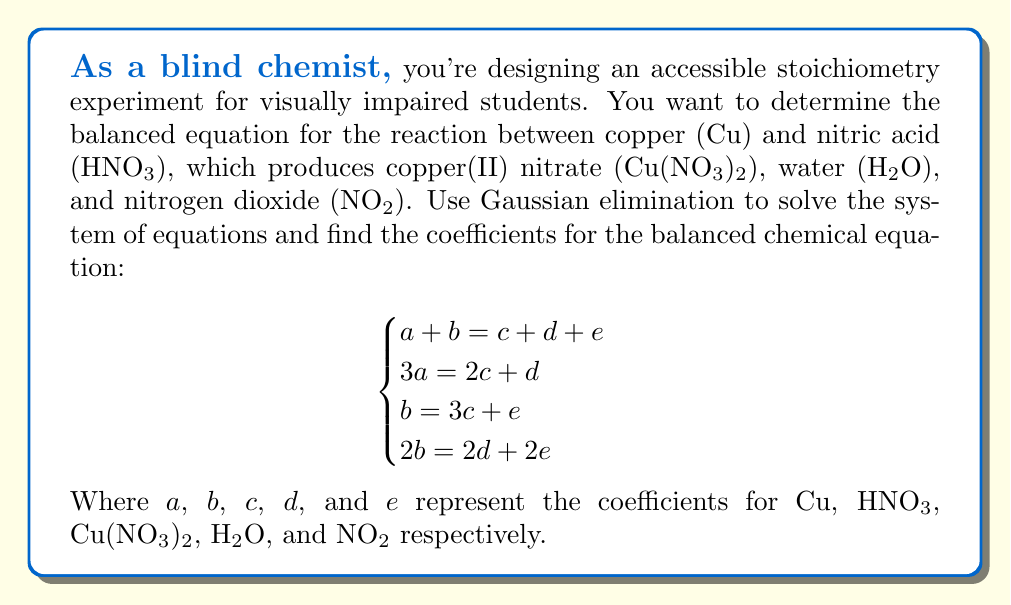Can you solve this math problem? Let's solve this system using Gaussian elimination:

1) First, we'll create an augmented matrix:

$$\begin{bmatrix}
1 & 1 & -1 & -1 & -1 & 0 \\
3 & 0 & -2 & -1 & 0 & 0 \\
0 & 1 & -3 & 0 & -1 & 0 \\
0 & 2 & 0 & -2 & -2 & 0
\end{bmatrix}$$

2) Multiply row 1 by -3 and add to row 2:

$$\begin{bmatrix}
1 & 1 & -1 & -1 & -1 & 0 \\
0 & -3 & 1 & 2 & 3 & 0 \\
0 & 1 & -3 & 0 & -1 & 0 \\
0 & 2 & 0 & -2 & -2 & 0
\end{bmatrix}$$

3) Add row 2 to 3 times row 3:

$$\begin{bmatrix}
1 & 1 & -1 & -1 & -1 & 0 \\
0 & -3 & 1 & 2 & 3 & 0 \\
0 & 0 & -8 & 2 & 0 & 0 \\
0 & 2 & 0 & -2 & -2 & 0
\end{bmatrix}$$

4) Multiply row 3 by -1/8:

$$\begin{bmatrix}
1 & 1 & -1 & -1 & -1 & 0 \\
0 & -3 & 1 & 2 & 3 & 0 \\
0 & 0 & 1 & -1/4 & 0 & 0 \\
0 & 2 & 0 & -2 & -2 & 0
\end{bmatrix}$$

5) Use row 3 to eliminate column 3 in other rows:

$$\begin{bmatrix}
1 & 1 & 0 & -5/4 & -1 & 0 \\
0 & -3 & 0 & 9/4 & 3 & 0 \\
0 & 0 & 1 & -1/4 & 0 & 0 \\
0 & 2 & 0 & -2 & -2 & 0
\end{bmatrix}$$

6) Add 3 times row 2 to 2 times row 4:

$$\begin{bmatrix}
1 & 1 & 0 & -5/4 & -1 & 0 \\
0 & -3 & 0 & 9/4 & 3 & 0 \\
0 & 0 & 1 & -1/4 & 0 & 0 \\
0 & 0 & 0 & -1/2 & 5 & 0
\end{bmatrix}$$

7) Multiply row 4 by -2:

$$\begin{bmatrix}
1 & 1 & 0 & -5/4 & -1 & 0 \\
0 & -3 & 0 & 9/4 & 3 & 0 \\
0 & 0 & 1 & -1/4 & 0 & 0 \\
0 & 0 & 0 & 1 & -10 & 0
\end{bmatrix}$$

8) Use row 4 to eliminate column 4 in other rows:

$$\begin{bmatrix}
1 & 1 & 0 & 0 & -13.25 & 0 \\
0 & -3 & 0 & 0 & 25.25 & 0 \\
0 & 0 & 1 & 0 & -2.5 & 0 \\
0 & 0 & 0 & 1 & -10 & 0
\end{bmatrix}$$

9) The system is now in row echelon form. We can see that e (NO₂) is a free variable. Let's set e = 2 for simplicity.

10) Back-substituting:
   d = 20
   c = 5
   b = 4e + 3c = 8 + 15 = 23
   a = 13.25e + c = 26.5 + 5 = 31.5

11) Multiplying all coefficients by 2 to get integer values:
   Cu: 63, HNO₃: 46, Cu(NO₃)₂: 10, H₂O: 40, NO₂: 4

Therefore, the balanced equation is:

63Cu + 46HNO₃ → 10Cu(NO₃)₂ + 40H₂O + 4NO₂
Answer: 63Cu + 46HNO₃ → 10Cu(NO₃)₂ + 40H₂O + 4NO₂ 